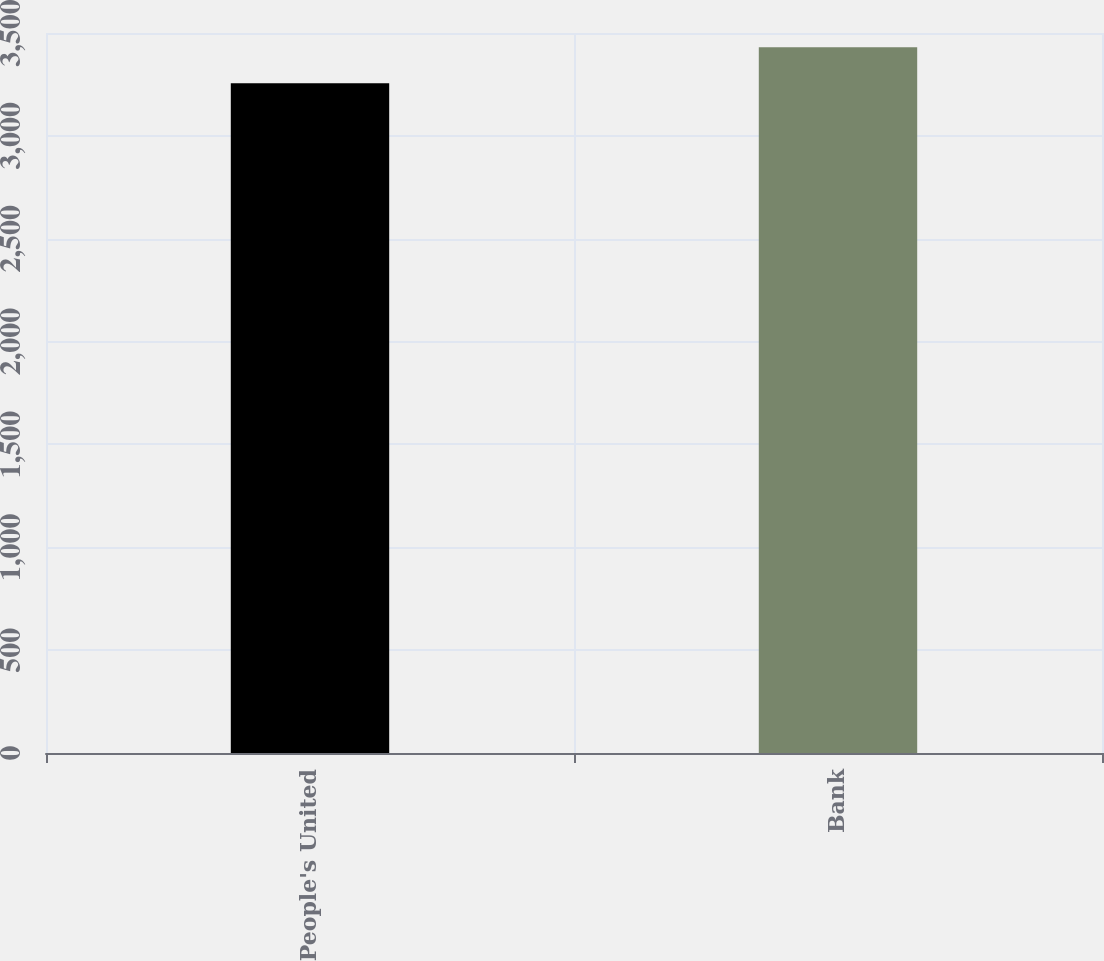Convert chart. <chart><loc_0><loc_0><loc_500><loc_500><bar_chart><fcel>People's United<fcel>Bank<nl><fcel>3256.1<fcel>3430.5<nl></chart> 